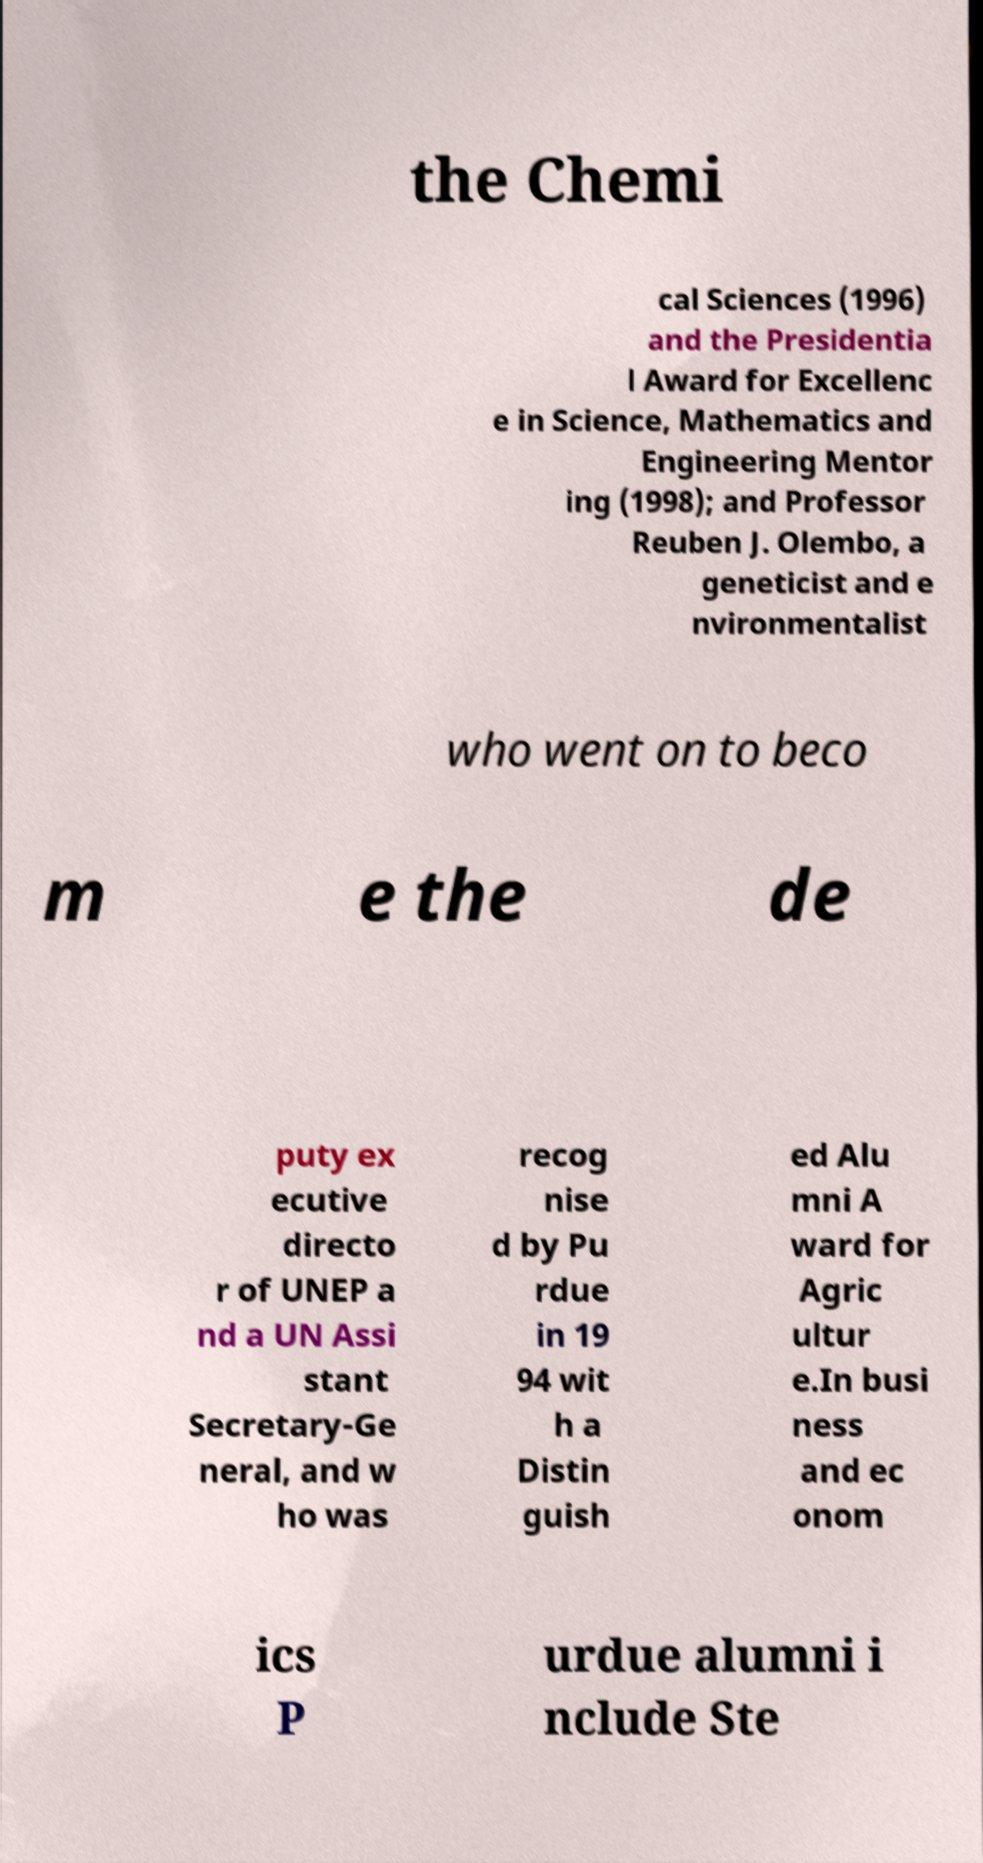There's text embedded in this image that I need extracted. Can you transcribe it verbatim? the Chemi cal Sciences (1996) and the Presidentia l Award for Excellenc e in Science, Mathematics and Engineering Mentor ing (1998); and Professor Reuben J. Olembo, a geneticist and e nvironmentalist who went on to beco m e the de puty ex ecutive directo r of UNEP a nd a UN Assi stant Secretary-Ge neral, and w ho was recog nise d by Pu rdue in 19 94 wit h a Distin guish ed Alu mni A ward for Agric ultur e.In busi ness and ec onom ics P urdue alumni i nclude Ste 